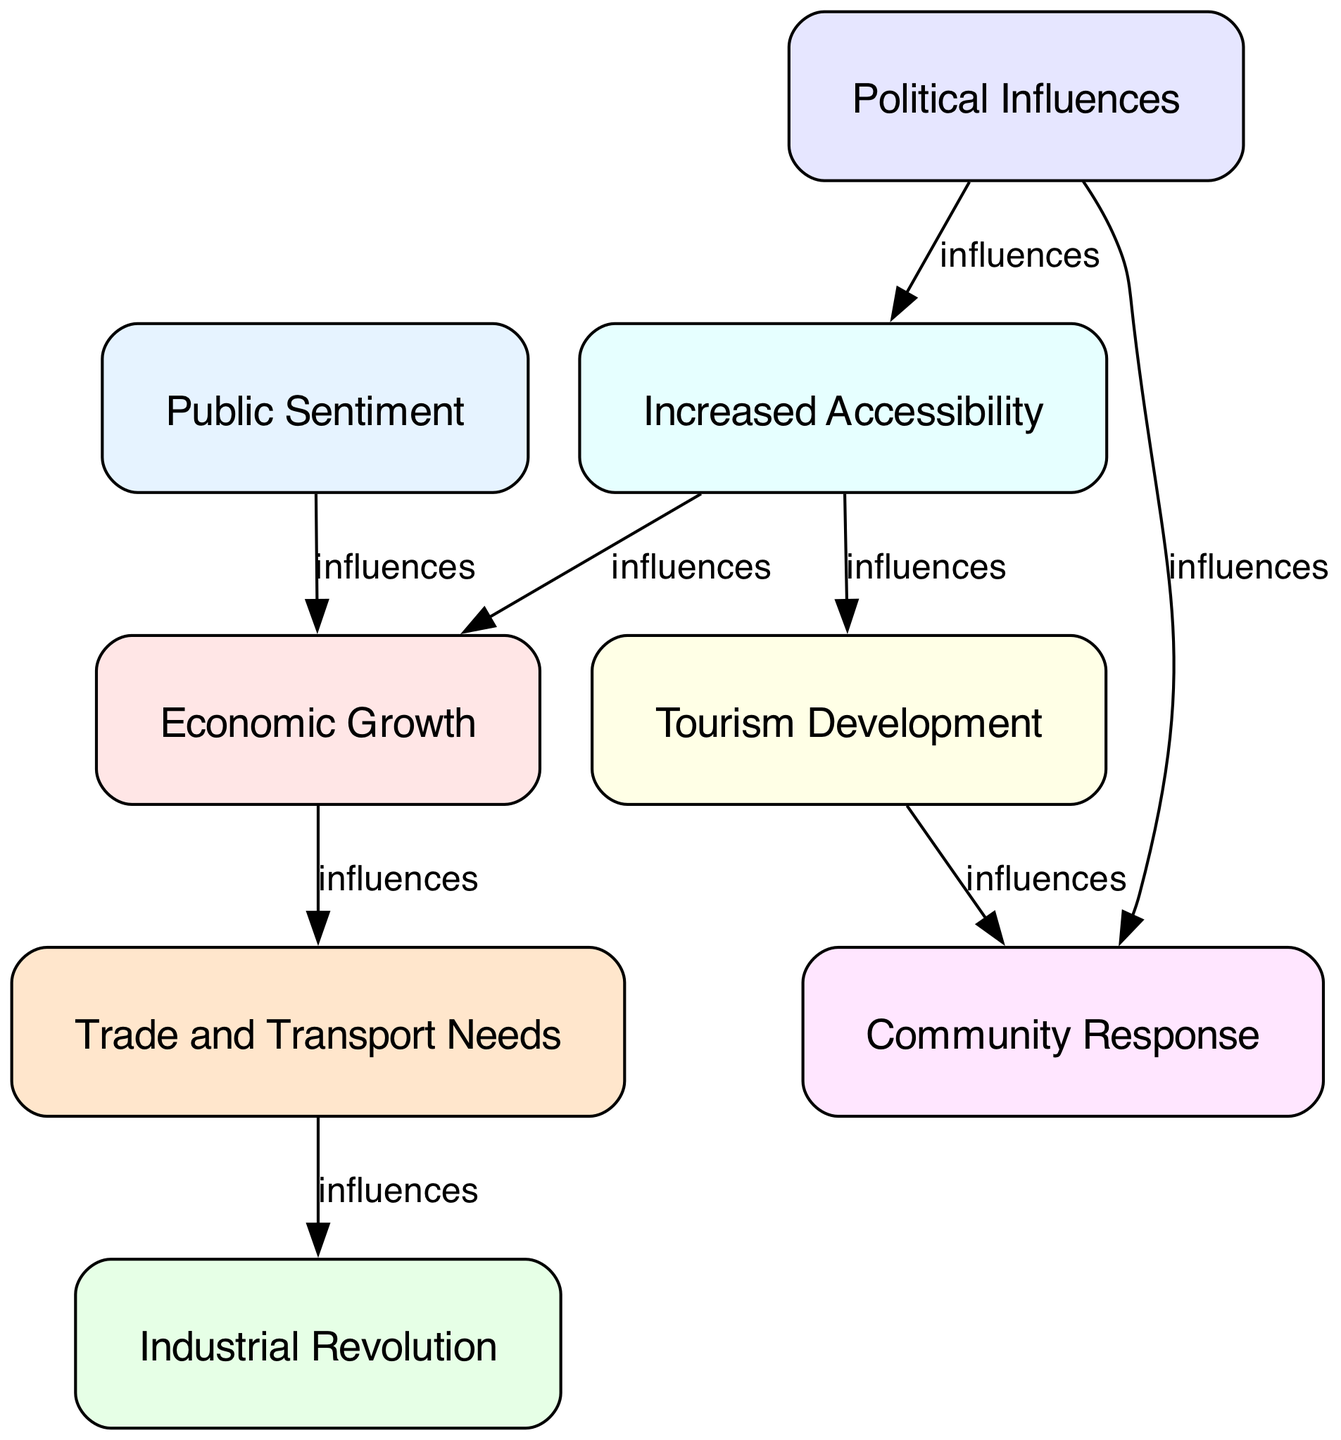What is the total number of nodes in the diagram? The diagram shows a total of 8 nodes representing different factors influencing the construction of the Swansea and Mumbles Railway. These nodes are Public Sentiment, Economic Growth, Industrial Revolution, Tourism Development, Political Influences, Community Response, Increased Accessibility, and Trade and Transport Needs.
Answer: 8 Which node influences Economic Growth? The diagram indicates that Public Sentiment influences Economic Growth, as there is a direct directed edge leading from Public Sentiment to Economic Growth.
Answer: Public Sentiment What relationship exists between Trade Transport and Industrial Revolution? The directed graph shows that Trade Transport is influenced by Economic Growth, which itself is influenced by Public Sentiment. Subsequently, Trade Transport influences the Industrial Revolution, creating a multi-step chain of influence from Public Sentiment to Industrial Revolution through Economic Growth and Trade Transport.
Answer: influences Which nodes are influenced by Political Influences? The diagram shows that Political Influences has edges leading to two nodes: Community Response and Increased Accessibility. Hence, Political Influences affects both of these factors directly.
Answer: Community Response, Increased Accessibility In how many instances does Accessibility appear as an influencing factor? Accessibility appears as an influencing factor in two relationships in the diagram. It influences both Economic Growth and Tourism, displaying the importance of accessibility in economic and tourist development within the context of the railway.
Answer: 2 What is the main connection that links Tourism Development to Accessibility? Accessibility influences Tourism Development directly. The directed edge from Accessibility to Tourism Development indicates that increased accessibility is seen as a major factor contributing to the development of tourism in the area, especially with the construction of the railway.
Answer: influences Which factor has no incoming edges in the diagram? The only factor with no incoming edges is Public Sentiment, indicating it is the root influencing factor that impacts Economic Growth, and indirectly other factors, but does not receive influence from any other factors in the diagram.
Answer: Public Sentiment How many edges are there in total in the diagram? The diagram has 8 edges connecting the various factors, indicating the different relations and influences between them. Each edge represents a directed influence from one factor to another, showcasing the complex interplay of social and economic factors.
Answer: 8 Which factor demonstrates the most direct influence by connecting through the most edges? Economic Growth is influenced by both Public Sentiment and Accessibility, and in turn influences Trade Transport, which then influences the Industrial Revolution. This demonstrates that Economic Growth serves as a central hub linking various other factors together through its edges.
Answer: Economic Growth 